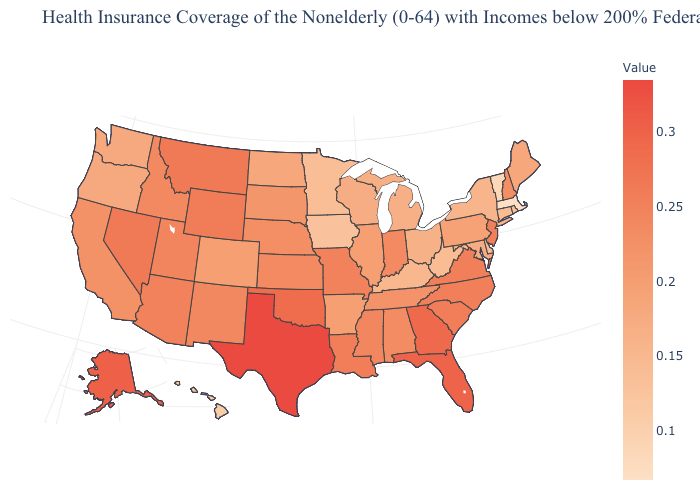Does Missouri have the highest value in the MidWest?
Keep it brief. Yes. Which states have the highest value in the USA?
Answer briefly. Texas. Does Hawaii have a higher value than Wisconsin?
Be succinct. No. Does Alabama have the highest value in the USA?
Be succinct. No. Which states hav the highest value in the West?
Concise answer only. Alaska. Does North Dakota have a higher value than Georgia?
Give a very brief answer. No. Among the states that border Wisconsin , does Illinois have the highest value?
Concise answer only. Yes. Among the states that border Delaware , which have the lowest value?
Concise answer only. Maryland. Does Massachusetts have the lowest value in the USA?
Give a very brief answer. Yes. 